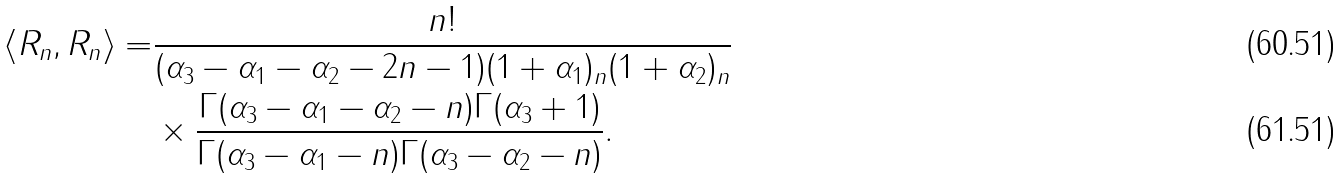<formula> <loc_0><loc_0><loc_500><loc_500>\langle R _ { n } , R _ { n } \rangle = & \frac { n ! } { ( \alpha _ { 3 } - \alpha _ { 1 } - \alpha _ { 2 } - 2 n - 1 ) ( 1 + \alpha _ { 1 } ) _ { n } ( 1 + \alpha _ { 2 } ) _ { n } } \\ & \times \frac { \Gamma ( \alpha _ { 3 } - \alpha _ { 1 } - \alpha _ { 2 } - n ) \Gamma ( \alpha _ { 3 } + 1 ) } { \Gamma ( \alpha _ { 3 } - \alpha _ { 1 } - n ) \Gamma ( \alpha _ { 3 } - \alpha _ { 2 } - n ) } .</formula> 